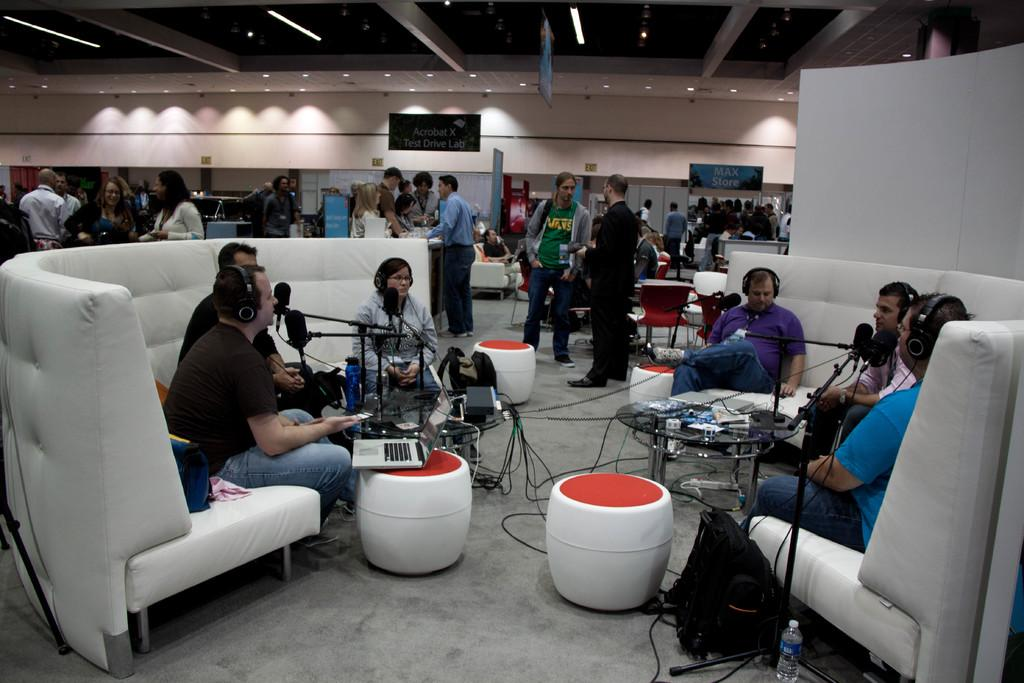What are the people in the image doing? There is a group of people sitting on a couch in the image. What object is in front of the group? The group has a laptop in front of them. What can be seen in front of the laptop? There is a microphone stand in front of the group. What is happening in the background of the image? There are people standing in the background. What type of bone is being used as a microphone in the image? There is no bone being used as a microphone in the image; it is a microphone stand. What color is the gold used to decorate the laptop in the image? There is no gold decoration on the laptop in the image. 